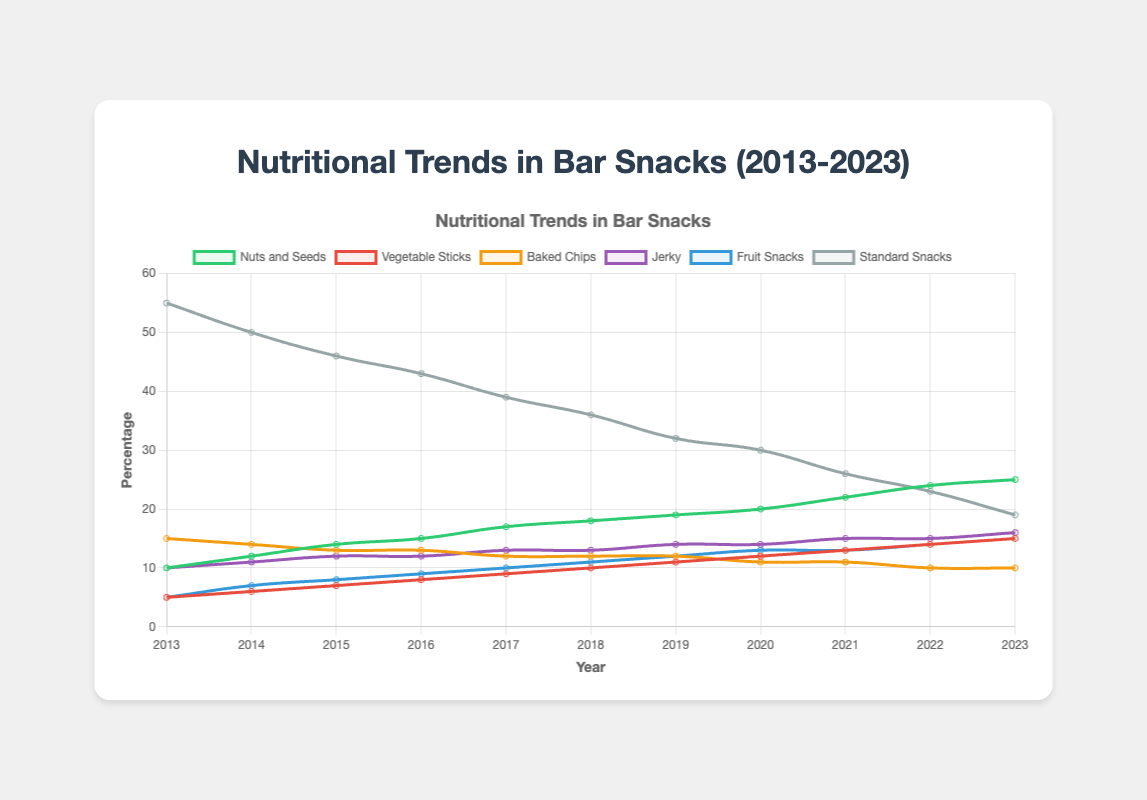What year had the highest percentage of sessions with nutritious snacks? Look at the plot and identify the year with the peak percentage of sessions indicated by the curve. In this case, it's the year at the end of the curve.
Answer: 2023 Comparing the percentages of 'nuts and seeds' and 'standard snacks' in 2020, which one was higher? Check the plot for 2020 and compare the heights of the lines representing 'nuts and seeds' and 'standard snacks'. 'Nuts and seeds' is at 20%, and 'standard snacks' is at 30%, so 'standard snacks' is higher.
Answer: Standard snacks What is the difference in percentages between 'vegetable sticks' in 2013 and 2023? Find the values for 'vegetable sticks' in 2013 (5%) and 2023 (15%) by looking at the lines and their corresponding years. Calculate the difference: 15% - 5% = 10%.
Answer: 10% What color line represents 'fruit snacks'? Identify the color of the line representing 'fruit snacks' from its label in the legend alongside the plot.
Answer: Blue On average, how much did the percentage of 'baked chips' change per year from 2013 to 2023? Find the starting (15%) and ending percentages (10%) for 'baked chips'. Calculate the total change: 15% - 10% = 5%. Since this change spans 10 years, average yearly change is 5% / 10 years = 0.5% per year.
Answer: 0.5% In what year did 'nuts and seeds' surpass 'standard snacks' in percentage? Identify the year where the line for 'nuts and seeds' rises above the line for 'standard snacks' by following both lines through the years. This occurs in 2020.
Answer: 2020 What trend can be observed in the percentage of 'jerky' over the decade? Observe the line for 'jerky'. Note whether it is generally increasing, decreasing, or stable from 2013 to 2023. 'Jerky' shows a rising trend.
Answer: Increasing trend How does the percentage of 'fruit snacks' in 2017 compare to 2023? Check the percentages for 'fruit snacks' in 2017 (10%) and 2023 (15%) and compare them.
Answer: 2023 is higher What is the sum of percentages for 'nuts and seeds' and 'vegetable sticks' in 2023? Find the individual percentages for 'nuts and seeds' (25%) and 'vegetable sticks' (15%) in 2023 and add them up: 25% + 15% = 40%.
Answer: 40% Which snack showed the most significant decline in percentage from 2013 to 2023? Compare the starting and ending percentages for all snack types. Identify the snack with the largest decrease. 'Standard snacks' dropped from 55% in 2013 to 19% in 2023, the most significant decline.
Answer: Standard snacks 